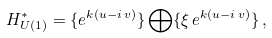<formula> <loc_0><loc_0><loc_500><loc_500>H _ { U ( 1 ) } ^ { * } = \{ e ^ { k ( u - i \, v ) } \} \bigoplus \{ \xi \, e ^ { k ( u - i \, v ) } \} \, ,</formula> 